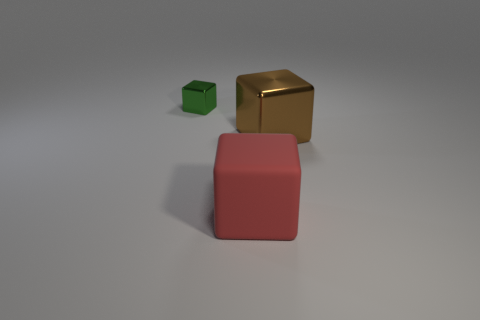Does the shiny thing that is right of the small cube have the same shape as the shiny object to the left of the red cube?
Offer a terse response. Yes. What size is the metal object left of the brown metallic block?
Your answer should be compact. Small. There is a metallic block to the left of the big red block that is in front of the brown cube; what is its size?
Ensure brevity in your answer.  Small. Is the number of large matte objects greater than the number of brown balls?
Make the answer very short. Yes. Are there more metallic blocks in front of the big brown shiny object than rubber cubes left of the small shiny thing?
Offer a very short reply. No. There is a thing that is left of the brown thing and behind the large red cube; how big is it?
Offer a terse response. Small. How many yellow spheres are the same size as the red object?
Make the answer very short. 0. There is a object on the right side of the big red cube; is it the same shape as the tiny green object?
Provide a short and direct response. Yes. Is the number of brown metal blocks on the right side of the tiny shiny block less than the number of small brown cubes?
Your answer should be very brief. No. Is the shape of the green object the same as the large object that is left of the brown metal cube?
Ensure brevity in your answer.  Yes. 